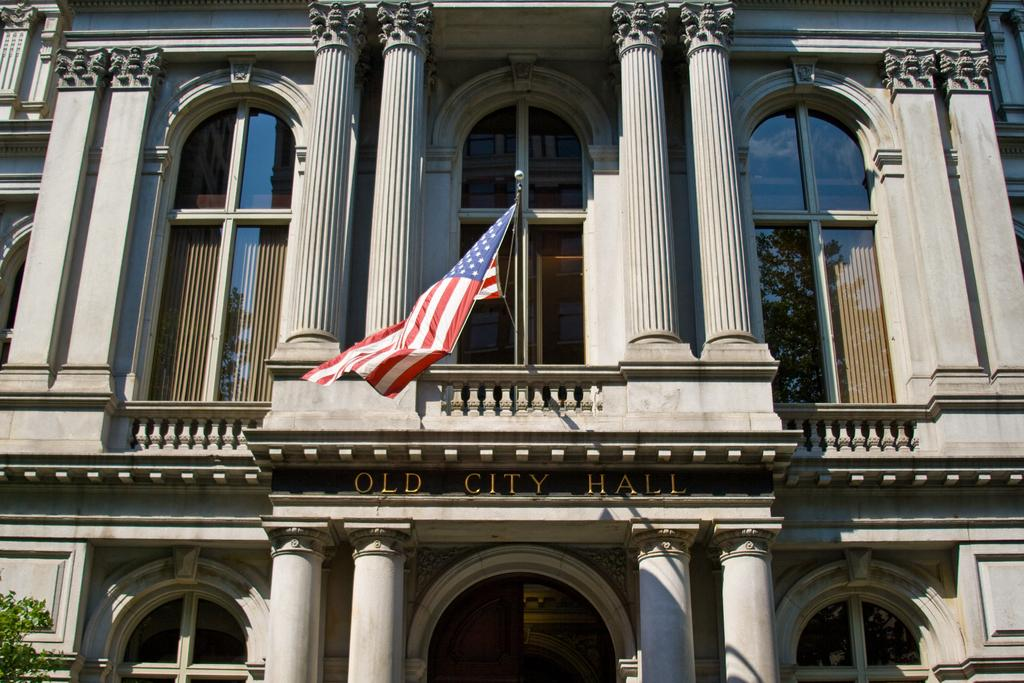What is the main structure in the center of the image? There is a building in the center of the image. What architectural features can be seen on the building? The building has pillars and windows. What additional objects are present in the image? There is a board, a door, a flag, and a pole in the image. Where is the tree located in the image? The tree is in the bottom left corner of the image. What letters are being played by the band in the image? There is no band present in the image, so it is not possible to determine what letters they might be playing. 